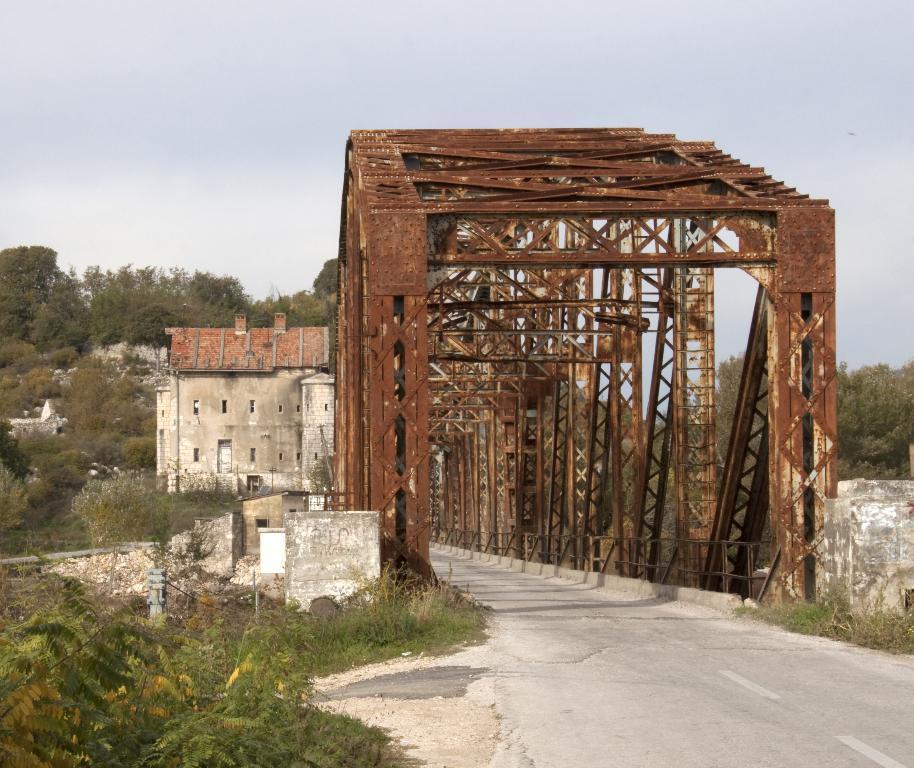In one or two sentences, can you explain what this image depicts? In front of the image there is a metal rod bridge. There are plants, trees, buildings. At the top of the image there is sky. 